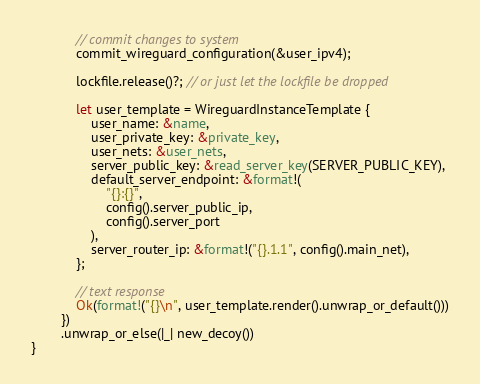Convert code to text. <code><loc_0><loc_0><loc_500><loc_500><_Rust_>            // commit changes to system
            commit_wireguard_configuration(&user_ipv4);

            lockfile.release()?; // or just let the lockfile be dropped

            let user_template = WireguardInstanceTemplate {
                user_name: &name,
                user_private_key: &private_key,
                user_nets: &user_nets,
                server_public_key: &read_server_key(SERVER_PUBLIC_KEY),
                default_server_endpoint: &format!(
                    "{}:{}",
                    config().server_public_ip,
                    config().server_port
                ),
                server_router_ip: &format!("{}.1.1", config().main_net),
            };

            // text response
            Ok(format!("{}\n", user_template.render().unwrap_or_default()))
        })
        .unwrap_or_else(|_| new_decoy())
}
</code> 